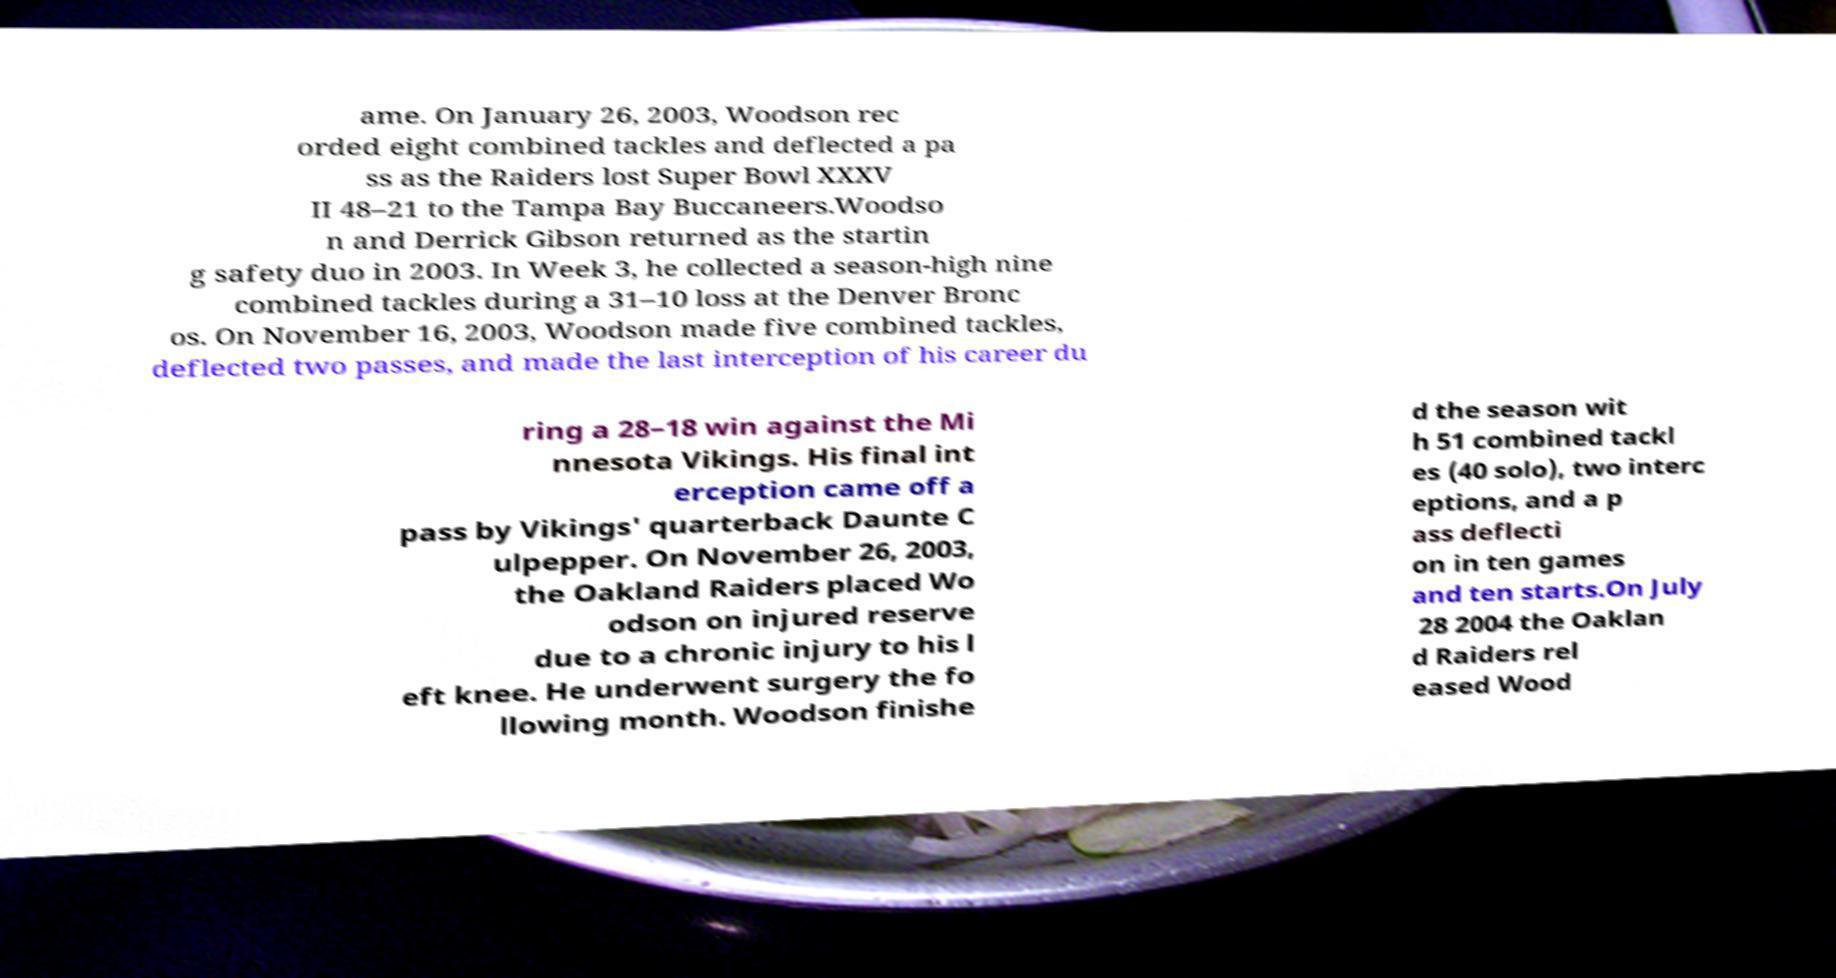Please read and relay the text visible in this image. What does it say? ame. On January 26, 2003, Woodson rec orded eight combined tackles and deflected a pa ss as the Raiders lost Super Bowl XXXV II 48–21 to the Tampa Bay Buccaneers.Woodso n and Derrick Gibson returned as the startin g safety duo in 2003. In Week 3, he collected a season-high nine combined tackles during a 31–10 loss at the Denver Bronc os. On November 16, 2003, Woodson made five combined tackles, deflected two passes, and made the last interception of his career du ring a 28–18 win against the Mi nnesota Vikings. His final int erception came off a pass by Vikings' quarterback Daunte C ulpepper. On November 26, 2003, the Oakland Raiders placed Wo odson on injured reserve due to a chronic injury to his l eft knee. He underwent surgery the fo llowing month. Woodson finishe d the season wit h 51 combined tackl es (40 solo), two interc eptions, and a p ass deflecti on in ten games and ten starts.On July 28 2004 the Oaklan d Raiders rel eased Wood 